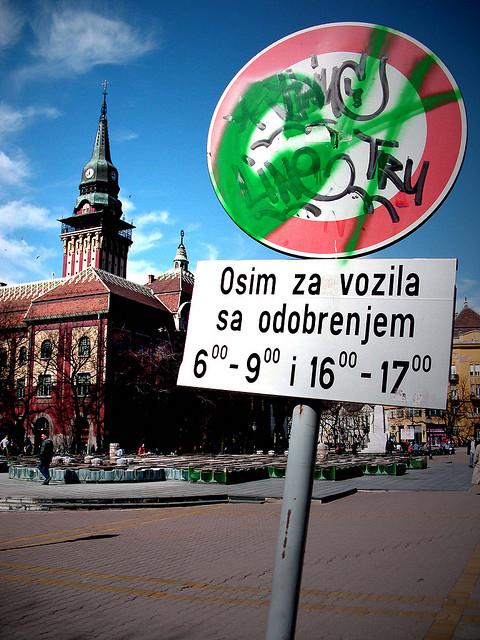What color is the graffiti?
Answer briefly. Green. How many languages are on the sign?
Give a very brief answer. 2. Is this scene from America?
Concise answer only. No. What is written in this picture?
Concise answer only. Osim za vozila sa odobrenjem. 